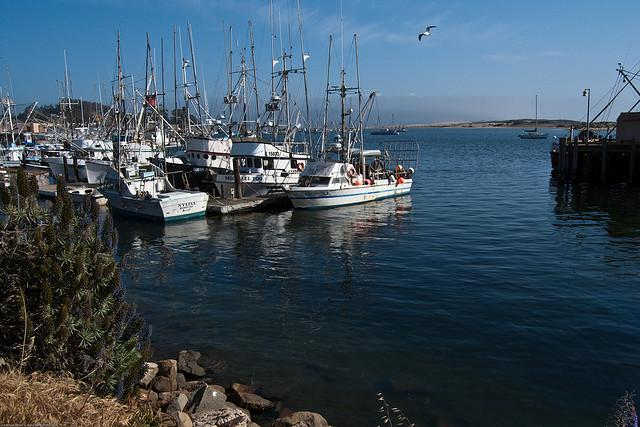Why are the boats stationary?

Choices:
A) unseaworthy
B) no gas
C) docked
D) bad weather docked 